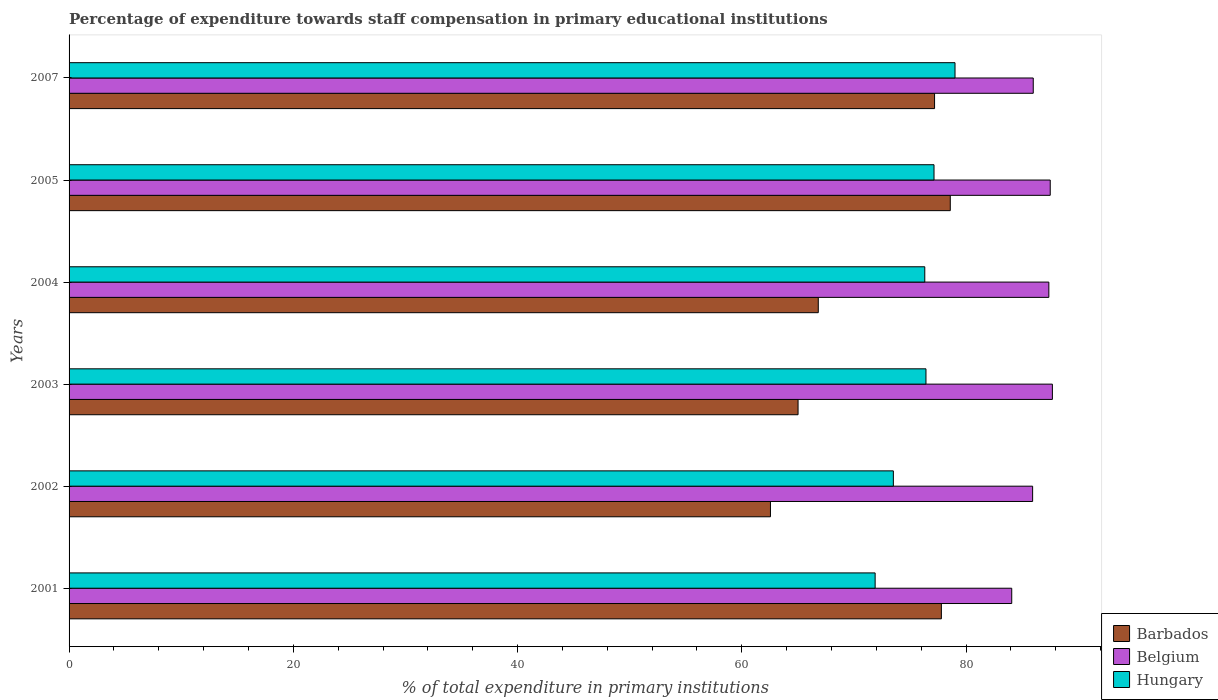How many groups of bars are there?
Your answer should be very brief. 6. Are the number of bars per tick equal to the number of legend labels?
Provide a succinct answer. Yes. What is the label of the 2nd group of bars from the top?
Ensure brevity in your answer.  2005. In how many cases, is the number of bars for a given year not equal to the number of legend labels?
Ensure brevity in your answer.  0. What is the percentage of expenditure towards staff compensation in Belgium in 2007?
Provide a succinct answer. 85.99. Across all years, what is the maximum percentage of expenditure towards staff compensation in Barbados?
Keep it short and to the point. 78.59. Across all years, what is the minimum percentage of expenditure towards staff compensation in Belgium?
Offer a very short reply. 84.07. In which year was the percentage of expenditure towards staff compensation in Barbados maximum?
Keep it short and to the point. 2005. What is the total percentage of expenditure towards staff compensation in Belgium in the graph?
Offer a terse response. 518.59. What is the difference between the percentage of expenditure towards staff compensation in Belgium in 2001 and that in 2003?
Your answer should be very brief. -3.63. What is the difference between the percentage of expenditure towards staff compensation in Barbados in 2001 and the percentage of expenditure towards staff compensation in Belgium in 2002?
Provide a short and direct response. -8.14. What is the average percentage of expenditure towards staff compensation in Hungary per year?
Your answer should be very brief. 75.72. In the year 2003, what is the difference between the percentage of expenditure towards staff compensation in Belgium and percentage of expenditure towards staff compensation in Hungary?
Offer a terse response. 11.28. What is the ratio of the percentage of expenditure towards staff compensation in Barbados in 2001 to that in 2003?
Give a very brief answer. 1.2. What is the difference between the highest and the second highest percentage of expenditure towards staff compensation in Hungary?
Make the answer very short. 1.87. What is the difference between the highest and the lowest percentage of expenditure towards staff compensation in Barbados?
Your answer should be very brief. 16.04. In how many years, is the percentage of expenditure towards staff compensation in Belgium greater than the average percentage of expenditure towards staff compensation in Belgium taken over all years?
Your answer should be compact. 3. Is the sum of the percentage of expenditure towards staff compensation in Hungary in 2001 and 2004 greater than the maximum percentage of expenditure towards staff compensation in Barbados across all years?
Give a very brief answer. Yes. What does the 3rd bar from the top in 2003 represents?
Give a very brief answer. Barbados. What does the 1st bar from the bottom in 2002 represents?
Provide a short and direct response. Barbados. How many bars are there?
Offer a terse response. 18. How many years are there in the graph?
Your answer should be compact. 6. What is the difference between two consecutive major ticks on the X-axis?
Your response must be concise. 20. How many legend labels are there?
Your response must be concise. 3. What is the title of the graph?
Your answer should be compact. Percentage of expenditure towards staff compensation in primary educational institutions. Does "Australia" appear as one of the legend labels in the graph?
Ensure brevity in your answer.  No. What is the label or title of the X-axis?
Make the answer very short. % of total expenditure in primary institutions. What is the % of total expenditure in primary institutions in Barbados in 2001?
Your answer should be compact. 77.8. What is the % of total expenditure in primary institutions of Belgium in 2001?
Your response must be concise. 84.07. What is the % of total expenditure in primary institutions in Hungary in 2001?
Provide a short and direct response. 71.89. What is the % of total expenditure in primary institutions in Barbados in 2002?
Ensure brevity in your answer.  62.55. What is the % of total expenditure in primary institutions in Belgium in 2002?
Keep it short and to the point. 85.94. What is the % of total expenditure in primary institutions of Hungary in 2002?
Ensure brevity in your answer.  73.52. What is the % of total expenditure in primary institutions of Barbados in 2003?
Your response must be concise. 65.02. What is the % of total expenditure in primary institutions of Belgium in 2003?
Your answer should be very brief. 87.7. What is the % of total expenditure in primary institutions of Hungary in 2003?
Offer a very short reply. 76.42. What is the % of total expenditure in primary institutions of Barbados in 2004?
Offer a terse response. 66.82. What is the % of total expenditure in primary institutions in Belgium in 2004?
Your answer should be very brief. 87.38. What is the % of total expenditure in primary institutions of Hungary in 2004?
Provide a short and direct response. 76.32. What is the % of total expenditure in primary institutions of Barbados in 2005?
Keep it short and to the point. 78.59. What is the % of total expenditure in primary institutions of Belgium in 2005?
Provide a succinct answer. 87.51. What is the % of total expenditure in primary institutions of Hungary in 2005?
Give a very brief answer. 77.14. What is the % of total expenditure in primary institutions in Barbados in 2007?
Your answer should be very brief. 77.19. What is the % of total expenditure in primary institutions of Belgium in 2007?
Offer a very short reply. 85.99. What is the % of total expenditure in primary institutions in Hungary in 2007?
Your answer should be very brief. 79.01. Across all years, what is the maximum % of total expenditure in primary institutions in Barbados?
Make the answer very short. 78.59. Across all years, what is the maximum % of total expenditure in primary institutions in Belgium?
Keep it short and to the point. 87.7. Across all years, what is the maximum % of total expenditure in primary institutions in Hungary?
Ensure brevity in your answer.  79.01. Across all years, what is the minimum % of total expenditure in primary institutions in Barbados?
Ensure brevity in your answer.  62.55. Across all years, what is the minimum % of total expenditure in primary institutions of Belgium?
Your response must be concise. 84.07. Across all years, what is the minimum % of total expenditure in primary institutions in Hungary?
Provide a short and direct response. 71.89. What is the total % of total expenditure in primary institutions of Barbados in the graph?
Provide a succinct answer. 427.97. What is the total % of total expenditure in primary institutions in Belgium in the graph?
Your response must be concise. 518.59. What is the total % of total expenditure in primary institutions of Hungary in the graph?
Your answer should be very brief. 454.3. What is the difference between the % of total expenditure in primary institutions in Barbados in 2001 and that in 2002?
Provide a succinct answer. 15.24. What is the difference between the % of total expenditure in primary institutions of Belgium in 2001 and that in 2002?
Provide a short and direct response. -1.86. What is the difference between the % of total expenditure in primary institutions of Hungary in 2001 and that in 2002?
Ensure brevity in your answer.  -1.62. What is the difference between the % of total expenditure in primary institutions in Barbados in 2001 and that in 2003?
Keep it short and to the point. 12.78. What is the difference between the % of total expenditure in primary institutions in Belgium in 2001 and that in 2003?
Your response must be concise. -3.63. What is the difference between the % of total expenditure in primary institutions of Hungary in 2001 and that in 2003?
Provide a short and direct response. -4.53. What is the difference between the % of total expenditure in primary institutions in Barbados in 2001 and that in 2004?
Give a very brief answer. 10.98. What is the difference between the % of total expenditure in primary institutions of Belgium in 2001 and that in 2004?
Provide a short and direct response. -3.31. What is the difference between the % of total expenditure in primary institutions in Hungary in 2001 and that in 2004?
Keep it short and to the point. -4.43. What is the difference between the % of total expenditure in primary institutions in Barbados in 2001 and that in 2005?
Offer a terse response. -0.8. What is the difference between the % of total expenditure in primary institutions of Belgium in 2001 and that in 2005?
Your response must be concise. -3.43. What is the difference between the % of total expenditure in primary institutions in Hungary in 2001 and that in 2005?
Provide a succinct answer. -5.25. What is the difference between the % of total expenditure in primary institutions of Barbados in 2001 and that in 2007?
Your answer should be very brief. 0.61. What is the difference between the % of total expenditure in primary institutions of Belgium in 2001 and that in 2007?
Provide a short and direct response. -1.92. What is the difference between the % of total expenditure in primary institutions in Hungary in 2001 and that in 2007?
Your response must be concise. -7.12. What is the difference between the % of total expenditure in primary institutions in Barbados in 2002 and that in 2003?
Offer a terse response. -2.46. What is the difference between the % of total expenditure in primary institutions of Belgium in 2002 and that in 2003?
Your answer should be very brief. -1.76. What is the difference between the % of total expenditure in primary institutions of Hungary in 2002 and that in 2003?
Give a very brief answer. -2.91. What is the difference between the % of total expenditure in primary institutions of Barbados in 2002 and that in 2004?
Keep it short and to the point. -4.26. What is the difference between the % of total expenditure in primary institutions of Belgium in 2002 and that in 2004?
Offer a terse response. -1.45. What is the difference between the % of total expenditure in primary institutions of Hungary in 2002 and that in 2004?
Provide a succinct answer. -2.8. What is the difference between the % of total expenditure in primary institutions in Barbados in 2002 and that in 2005?
Your answer should be compact. -16.04. What is the difference between the % of total expenditure in primary institutions in Belgium in 2002 and that in 2005?
Offer a very short reply. -1.57. What is the difference between the % of total expenditure in primary institutions in Hungary in 2002 and that in 2005?
Provide a short and direct response. -3.63. What is the difference between the % of total expenditure in primary institutions of Barbados in 2002 and that in 2007?
Your response must be concise. -14.64. What is the difference between the % of total expenditure in primary institutions of Belgium in 2002 and that in 2007?
Your answer should be very brief. -0.06. What is the difference between the % of total expenditure in primary institutions in Hungary in 2002 and that in 2007?
Provide a succinct answer. -5.5. What is the difference between the % of total expenditure in primary institutions in Barbados in 2003 and that in 2004?
Your response must be concise. -1.8. What is the difference between the % of total expenditure in primary institutions in Belgium in 2003 and that in 2004?
Provide a short and direct response. 0.32. What is the difference between the % of total expenditure in primary institutions in Hungary in 2003 and that in 2004?
Keep it short and to the point. 0.11. What is the difference between the % of total expenditure in primary institutions in Barbados in 2003 and that in 2005?
Ensure brevity in your answer.  -13.58. What is the difference between the % of total expenditure in primary institutions in Belgium in 2003 and that in 2005?
Give a very brief answer. 0.19. What is the difference between the % of total expenditure in primary institutions of Hungary in 2003 and that in 2005?
Your response must be concise. -0.72. What is the difference between the % of total expenditure in primary institutions of Barbados in 2003 and that in 2007?
Your response must be concise. -12.17. What is the difference between the % of total expenditure in primary institutions of Belgium in 2003 and that in 2007?
Keep it short and to the point. 1.71. What is the difference between the % of total expenditure in primary institutions in Hungary in 2003 and that in 2007?
Your answer should be compact. -2.59. What is the difference between the % of total expenditure in primary institutions of Barbados in 2004 and that in 2005?
Your answer should be compact. -11.77. What is the difference between the % of total expenditure in primary institutions in Belgium in 2004 and that in 2005?
Give a very brief answer. -0.12. What is the difference between the % of total expenditure in primary institutions of Hungary in 2004 and that in 2005?
Provide a short and direct response. -0.82. What is the difference between the % of total expenditure in primary institutions in Barbados in 2004 and that in 2007?
Your answer should be compact. -10.37. What is the difference between the % of total expenditure in primary institutions in Belgium in 2004 and that in 2007?
Your response must be concise. 1.39. What is the difference between the % of total expenditure in primary institutions in Hungary in 2004 and that in 2007?
Offer a terse response. -2.7. What is the difference between the % of total expenditure in primary institutions in Barbados in 2005 and that in 2007?
Your answer should be very brief. 1.4. What is the difference between the % of total expenditure in primary institutions of Belgium in 2005 and that in 2007?
Make the answer very short. 1.51. What is the difference between the % of total expenditure in primary institutions of Hungary in 2005 and that in 2007?
Provide a short and direct response. -1.87. What is the difference between the % of total expenditure in primary institutions in Barbados in 2001 and the % of total expenditure in primary institutions in Belgium in 2002?
Your answer should be compact. -8.14. What is the difference between the % of total expenditure in primary institutions of Barbados in 2001 and the % of total expenditure in primary institutions of Hungary in 2002?
Your response must be concise. 4.28. What is the difference between the % of total expenditure in primary institutions of Belgium in 2001 and the % of total expenditure in primary institutions of Hungary in 2002?
Your answer should be very brief. 10.56. What is the difference between the % of total expenditure in primary institutions of Barbados in 2001 and the % of total expenditure in primary institutions of Belgium in 2003?
Your response must be concise. -9.9. What is the difference between the % of total expenditure in primary institutions of Barbados in 2001 and the % of total expenditure in primary institutions of Hungary in 2003?
Provide a short and direct response. 1.37. What is the difference between the % of total expenditure in primary institutions in Belgium in 2001 and the % of total expenditure in primary institutions in Hungary in 2003?
Give a very brief answer. 7.65. What is the difference between the % of total expenditure in primary institutions of Barbados in 2001 and the % of total expenditure in primary institutions of Belgium in 2004?
Keep it short and to the point. -9.59. What is the difference between the % of total expenditure in primary institutions of Barbados in 2001 and the % of total expenditure in primary institutions of Hungary in 2004?
Provide a short and direct response. 1.48. What is the difference between the % of total expenditure in primary institutions in Belgium in 2001 and the % of total expenditure in primary institutions in Hungary in 2004?
Give a very brief answer. 7.75. What is the difference between the % of total expenditure in primary institutions in Barbados in 2001 and the % of total expenditure in primary institutions in Belgium in 2005?
Provide a succinct answer. -9.71. What is the difference between the % of total expenditure in primary institutions of Barbados in 2001 and the % of total expenditure in primary institutions of Hungary in 2005?
Provide a succinct answer. 0.66. What is the difference between the % of total expenditure in primary institutions in Belgium in 2001 and the % of total expenditure in primary institutions in Hungary in 2005?
Offer a very short reply. 6.93. What is the difference between the % of total expenditure in primary institutions in Barbados in 2001 and the % of total expenditure in primary institutions in Belgium in 2007?
Your answer should be compact. -8.19. What is the difference between the % of total expenditure in primary institutions of Barbados in 2001 and the % of total expenditure in primary institutions of Hungary in 2007?
Provide a short and direct response. -1.22. What is the difference between the % of total expenditure in primary institutions of Belgium in 2001 and the % of total expenditure in primary institutions of Hungary in 2007?
Your response must be concise. 5.06. What is the difference between the % of total expenditure in primary institutions in Barbados in 2002 and the % of total expenditure in primary institutions in Belgium in 2003?
Your answer should be very brief. -25.14. What is the difference between the % of total expenditure in primary institutions of Barbados in 2002 and the % of total expenditure in primary institutions of Hungary in 2003?
Offer a very short reply. -13.87. What is the difference between the % of total expenditure in primary institutions in Belgium in 2002 and the % of total expenditure in primary institutions in Hungary in 2003?
Offer a terse response. 9.51. What is the difference between the % of total expenditure in primary institutions in Barbados in 2002 and the % of total expenditure in primary institutions in Belgium in 2004?
Your response must be concise. -24.83. What is the difference between the % of total expenditure in primary institutions in Barbados in 2002 and the % of total expenditure in primary institutions in Hungary in 2004?
Offer a terse response. -13.76. What is the difference between the % of total expenditure in primary institutions of Belgium in 2002 and the % of total expenditure in primary institutions of Hungary in 2004?
Give a very brief answer. 9.62. What is the difference between the % of total expenditure in primary institutions in Barbados in 2002 and the % of total expenditure in primary institutions in Belgium in 2005?
Ensure brevity in your answer.  -24.95. What is the difference between the % of total expenditure in primary institutions in Barbados in 2002 and the % of total expenditure in primary institutions in Hungary in 2005?
Your answer should be compact. -14.59. What is the difference between the % of total expenditure in primary institutions of Belgium in 2002 and the % of total expenditure in primary institutions of Hungary in 2005?
Keep it short and to the point. 8.79. What is the difference between the % of total expenditure in primary institutions in Barbados in 2002 and the % of total expenditure in primary institutions in Belgium in 2007?
Make the answer very short. -23.44. What is the difference between the % of total expenditure in primary institutions of Barbados in 2002 and the % of total expenditure in primary institutions of Hungary in 2007?
Give a very brief answer. -16.46. What is the difference between the % of total expenditure in primary institutions in Belgium in 2002 and the % of total expenditure in primary institutions in Hungary in 2007?
Give a very brief answer. 6.92. What is the difference between the % of total expenditure in primary institutions of Barbados in 2003 and the % of total expenditure in primary institutions of Belgium in 2004?
Ensure brevity in your answer.  -22.37. What is the difference between the % of total expenditure in primary institutions in Barbados in 2003 and the % of total expenditure in primary institutions in Hungary in 2004?
Provide a short and direct response. -11.3. What is the difference between the % of total expenditure in primary institutions of Belgium in 2003 and the % of total expenditure in primary institutions of Hungary in 2004?
Give a very brief answer. 11.38. What is the difference between the % of total expenditure in primary institutions in Barbados in 2003 and the % of total expenditure in primary institutions in Belgium in 2005?
Give a very brief answer. -22.49. What is the difference between the % of total expenditure in primary institutions of Barbados in 2003 and the % of total expenditure in primary institutions of Hungary in 2005?
Offer a terse response. -12.12. What is the difference between the % of total expenditure in primary institutions in Belgium in 2003 and the % of total expenditure in primary institutions in Hungary in 2005?
Your answer should be very brief. 10.56. What is the difference between the % of total expenditure in primary institutions in Barbados in 2003 and the % of total expenditure in primary institutions in Belgium in 2007?
Offer a terse response. -20.98. What is the difference between the % of total expenditure in primary institutions in Barbados in 2003 and the % of total expenditure in primary institutions in Hungary in 2007?
Your response must be concise. -14. What is the difference between the % of total expenditure in primary institutions of Belgium in 2003 and the % of total expenditure in primary institutions of Hungary in 2007?
Offer a very short reply. 8.69. What is the difference between the % of total expenditure in primary institutions of Barbados in 2004 and the % of total expenditure in primary institutions of Belgium in 2005?
Your response must be concise. -20.69. What is the difference between the % of total expenditure in primary institutions of Barbados in 2004 and the % of total expenditure in primary institutions of Hungary in 2005?
Your response must be concise. -10.32. What is the difference between the % of total expenditure in primary institutions of Belgium in 2004 and the % of total expenditure in primary institutions of Hungary in 2005?
Ensure brevity in your answer.  10.24. What is the difference between the % of total expenditure in primary institutions in Barbados in 2004 and the % of total expenditure in primary institutions in Belgium in 2007?
Offer a terse response. -19.17. What is the difference between the % of total expenditure in primary institutions of Barbados in 2004 and the % of total expenditure in primary institutions of Hungary in 2007?
Your answer should be compact. -12.2. What is the difference between the % of total expenditure in primary institutions in Belgium in 2004 and the % of total expenditure in primary institutions in Hungary in 2007?
Your answer should be very brief. 8.37. What is the difference between the % of total expenditure in primary institutions of Barbados in 2005 and the % of total expenditure in primary institutions of Belgium in 2007?
Give a very brief answer. -7.4. What is the difference between the % of total expenditure in primary institutions in Barbados in 2005 and the % of total expenditure in primary institutions in Hungary in 2007?
Your response must be concise. -0.42. What is the difference between the % of total expenditure in primary institutions in Belgium in 2005 and the % of total expenditure in primary institutions in Hungary in 2007?
Your answer should be compact. 8.49. What is the average % of total expenditure in primary institutions of Barbados per year?
Offer a terse response. 71.33. What is the average % of total expenditure in primary institutions of Belgium per year?
Provide a succinct answer. 86.43. What is the average % of total expenditure in primary institutions of Hungary per year?
Your response must be concise. 75.72. In the year 2001, what is the difference between the % of total expenditure in primary institutions of Barbados and % of total expenditure in primary institutions of Belgium?
Your answer should be very brief. -6.28. In the year 2001, what is the difference between the % of total expenditure in primary institutions in Barbados and % of total expenditure in primary institutions in Hungary?
Provide a succinct answer. 5.91. In the year 2001, what is the difference between the % of total expenditure in primary institutions of Belgium and % of total expenditure in primary institutions of Hungary?
Keep it short and to the point. 12.18. In the year 2002, what is the difference between the % of total expenditure in primary institutions of Barbados and % of total expenditure in primary institutions of Belgium?
Offer a terse response. -23.38. In the year 2002, what is the difference between the % of total expenditure in primary institutions of Barbados and % of total expenditure in primary institutions of Hungary?
Give a very brief answer. -10.96. In the year 2002, what is the difference between the % of total expenditure in primary institutions in Belgium and % of total expenditure in primary institutions in Hungary?
Your answer should be very brief. 12.42. In the year 2003, what is the difference between the % of total expenditure in primary institutions of Barbados and % of total expenditure in primary institutions of Belgium?
Provide a short and direct response. -22.68. In the year 2003, what is the difference between the % of total expenditure in primary institutions of Barbados and % of total expenditure in primary institutions of Hungary?
Your answer should be compact. -11.41. In the year 2003, what is the difference between the % of total expenditure in primary institutions in Belgium and % of total expenditure in primary institutions in Hungary?
Offer a terse response. 11.28. In the year 2004, what is the difference between the % of total expenditure in primary institutions in Barbados and % of total expenditure in primary institutions in Belgium?
Offer a very short reply. -20.56. In the year 2004, what is the difference between the % of total expenditure in primary institutions of Barbados and % of total expenditure in primary institutions of Hungary?
Your answer should be compact. -9.5. In the year 2004, what is the difference between the % of total expenditure in primary institutions of Belgium and % of total expenditure in primary institutions of Hungary?
Your answer should be compact. 11.07. In the year 2005, what is the difference between the % of total expenditure in primary institutions of Barbados and % of total expenditure in primary institutions of Belgium?
Keep it short and to the point. -8.91. In the year 2005, what is the difference between the % of total expenditure in primary institutions of Barbados and % of total expenditure in primary institutions of Hungary?
Provide a short and direct response. 1.45. In the year 2005, what is the difference between the % of total expenditure in primary institutions of Belgium and % of total expenditure in primary institutions of Hungary?
Give a very brief answer. 10.37. In the year 2007, what is the difference between the % of total expenditure in primary institutions of Barbados and % of total expenditure in primary institutions of Belgium?
Ensure brevity in your answer.  -8.8. In the year 2007, what is the difference between the % of total expenditure in primary institutions in Barbados and % of total expenditure in primary institutions in Hungary?
Your answer should be very brief. -1.82. In the year 2007, what is the difference between the % of total expenditure in primary institutions of Belgium and % of total expenditure in primary institutions of Hungary?
Your response must be concise. 6.98. What is the ratio of the % of total expenditure in primary institutions of Barbados in 2001 to that in 2002?
Your answer should be compact. 1.24. What is the ratio of the % of total expenditure in primary institutions in Belgium in 2001 to that in 2002?
Provide a succinct answer. 0.98. What is the ratio of the % of total expenditure in primary institutions in Hungary in 2001 to that in 2002?
Ensure brevity in your answer.  0.98. What is the ratio of the % of total expenditure in primary institutions of Barbados in 2001 to that in 2003?
Keep it short and to the point. 1.2. What is the ratio of the % of total expenditure in primary institutions of Belgium in 2001 to that in 2003?
Offer a very short reply. 0.96. What is the ratio of the % of total expenditure in primary institutions in Hungary in 2001 to that in 2003?
Provide a short and direct response. 0.94. What is the ratio of the % of total expenditure in primary institutions in Barbados in 2001 to that in 2004?
Provide a short and direct response. 1.16. What is the ratio of the % of total expenditure in primary institutions of Belgium in 2001 to that in 2004?
Your answer should be compact. 0.96. What is the ratio of the % of total expenditure in primary institutions of Hungary in 2001 to that in 2004?
Keep it short and to the point. 0.94. What is the ratio of the % of total expenditure in primary institutions in Barbados in 2001 to that in 2005?
Your answer should be very brief. 0.99. What is the ratio of the % of total expenditure in primary institutions of Belgium in 2001 to that in 2005?
Your answer should be very brief. 0.96. What is the ratio of the % of total expenditure in primary institutions in Hungary in 2001 to that in 2005?
Keep it short and to the point. 0.93. What is the ratio of the % of total expenditure in primary institutions in Barbados in 2001 to that in 2007?
Provide a succinct answer. 1.01. What is the ratio of the % of total expenditure in primary institutions of Belgium in 2001 to that in 2007?
Your answer should be compact. 0.98. What is the ratio of the % of total expenditure in primary institutions of Hungary in 2001 to that in 2007?
Ensure brevity in your answer.  0.91. What is the ratio of the % of total expenditure in primary institutions in Barbados in 2002 to that in 2003?
Offer a very short reply. 0.96. What is the ratio of the % of total expenditure in primary institutions in Belgium in 2002 to that in 2003?
Your response must be concise. 0.98. What is the ratio of the % of total expenditure in primary institutions in Hungary in 2002 to that in 2003?
Offer a terse response. 0.96. What is the ratio of the % of total expenditure in primary institutions of Barbados in 2002 to that in 2004?
Give a very brief answer. 0.94. What is the ratio of the % of total expenditure in primary institutions in Belgium in 2002 to that in 2004?
Offer a very short reply. 0.98. What is the ratio of the % of total expenditure in primary institutions in Hungary in 2002 to that in 2004?
Provide a succinct answer. 0.96. What is the ratio of the % of total expenditure in primary institutions of Barbados in 2002 to that in 2005?
Your answer should be compact. 0.8. What is the ratio of the % of total expenditure in primary institutions in Belgium in 2002 to that in 2005?
Make the answer very short. 0.98. What is the ratio of the % of total expenditure in primary institutions of Hungary in 2002 to that in 2005?
Your response must be concise. 0.95. What is the ratio of the % of total expenditure in primary institutions in Barbados in 2002 to that in 2007?
Keep it short and to the point. 0.81. What is the ratio of the % of total expenditure in primary institutions in Belgium in 2002 to that in 2007?
Make the answer very short. 1. What is the ratio of the % of total expenditure in primary institutions of Hungary in 2002 to that in 2007?
Give a very brief answer. 0.93. What is the ratio of the % of total expenditure in primary institutions of Barbados in 2003 to that in 2004?
Provide a succinct answer. 0.97. What is the ratio of the % of total expenditure in primary institutions in Belgium in 2003 to that in 2004?
Your response must be concise. 1. What is the ratio of the % of total expenditure in primary institutions of Barbados in 2003 to that in 2005?
Offer a terse response. 0.83. What is the ratio of the % of total expenditure in primary institutions of Hungary in 2003 to that in 2005?
Ensure brevity in your answer.  0.99. What is the ratio of the % of total expenditure in primary institutions in Barbados in 2003 to that in 2007?
Keep it short and to the point. 0.84. What is the ratio of the % of total expenditure in primary institutions of Belgium in 2003 to that in 2007?
Keep it short and to the point. 1.02. What is the ratio of the % of total expenditure in primary institutions in Hungary in 2003 to that in 2007?
Keep it short and to the point. 0.97. What is the ratio of the % of total expenditure in primary institutions of Barbados in 2004 to that in 2005?
Make the answer very short. 0.85. What is the ratio of the % of total expenditure in primary institutions of Hungary in 2004 to that in 2005?
Keep it short and to the point. 0.99. What is the ratio of the % of total expenditure in primary institutions in Barbados in 2004 to that in 2007?
Offer a terse response. 0.87. What is the ratio of the % of total expenditure in primary institutions in Belgium in 2004 to that in 2007?
Make the answer very short. 1.02. What is the ratio of the % of total expenditure in primary institutions in Hungary in 2004 to that in 2007?
Provide a succinct answer. 0.97. What is the ratio of the % of total expenditure in primary institutions in Barbados in 2005 to that in 2007?
Provide a short and direct response. 1.02. What is the ratio of the % of total expenditure in primary institutions in Belgium in 2005 to that in 2007?
Provide a succinct answer. 1.02. What is the ratio of the % of total expenditure in primary institutions in Hungary in 2005 to that in 2007?
Keep it short and to the point. 0.98. What is the difference between the highest and the second highest % of total expenditure in primary institutions of Barbados?
Your answer should be compact. 0.8. What is the difference between the highest and the second highest % of total expenditure in primary institutions in Belgium?
Offer a very short reply. 0.19. What is the difference between the highest and the second highest % of total expenditure in primary institutions in Hungary?
Your response must be concise. 1.87. What is the difference between the highest and the lowest % of total expenditure in primary institutions of Barbados?
Your answer should be very brief. 16.04. What is the difference between the highest and the lowest % of total expenditure in primary institutions in Belgium?
Give a very brief answer. 3.63. What is the difference between the highest and the lowest % of total expenditure in primary institutions in Hungary?
Ensure brevity in your answer.  7.12. 